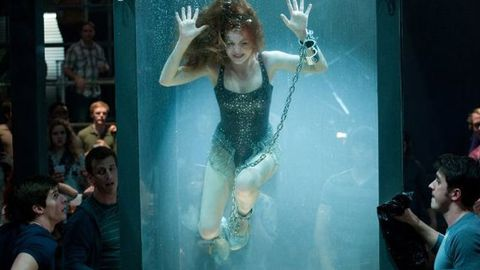What is this photo about? This photo captures a dramatic underwater scene where a person is performing an escape artist act, reminiscent of the stunts performed by the legendary Harry Houdini. The individual is submerged in a clear tank of water and is seen bound by chains and shackles, suggesting an escape attempt is imminent. The surrounding crowd appears captivated and anxious, indicating that this event is likely a live performance aimed at showcasing the person's ability to perform daring feats. The image evokes suspense and a strong emotional response from its audience. 